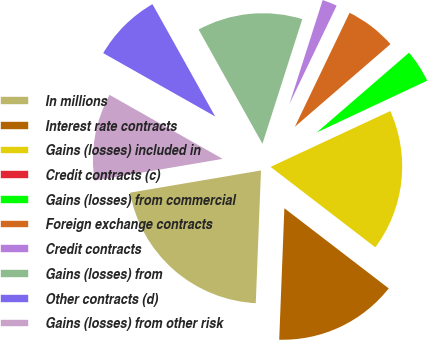Convert chart. <chart><loc_0><loc_0><loc_500><loc_500><pie_chart><fcel>In millions<fcel>Interest rate contracts<fcel>Gains (losses) included in<fcel>Credit contracts (c)<fcel>Gains (losses) from commercial<fcel>Foreign exchange contracts<fcel>Credit contracts<fcel>Gains (losses) from<fcel>Other contracts (d)<fcel>Gains (losses) from other risk<nl><fcel>21.7%<fcel>15.2%<fcel>17.37%<fcel>0.03%<fcel>4.37%<fcel>6.53%<fcel>2.2%<fcel>13.03%<fcel>8.7%<fcel>10.87%<nl></chart> 